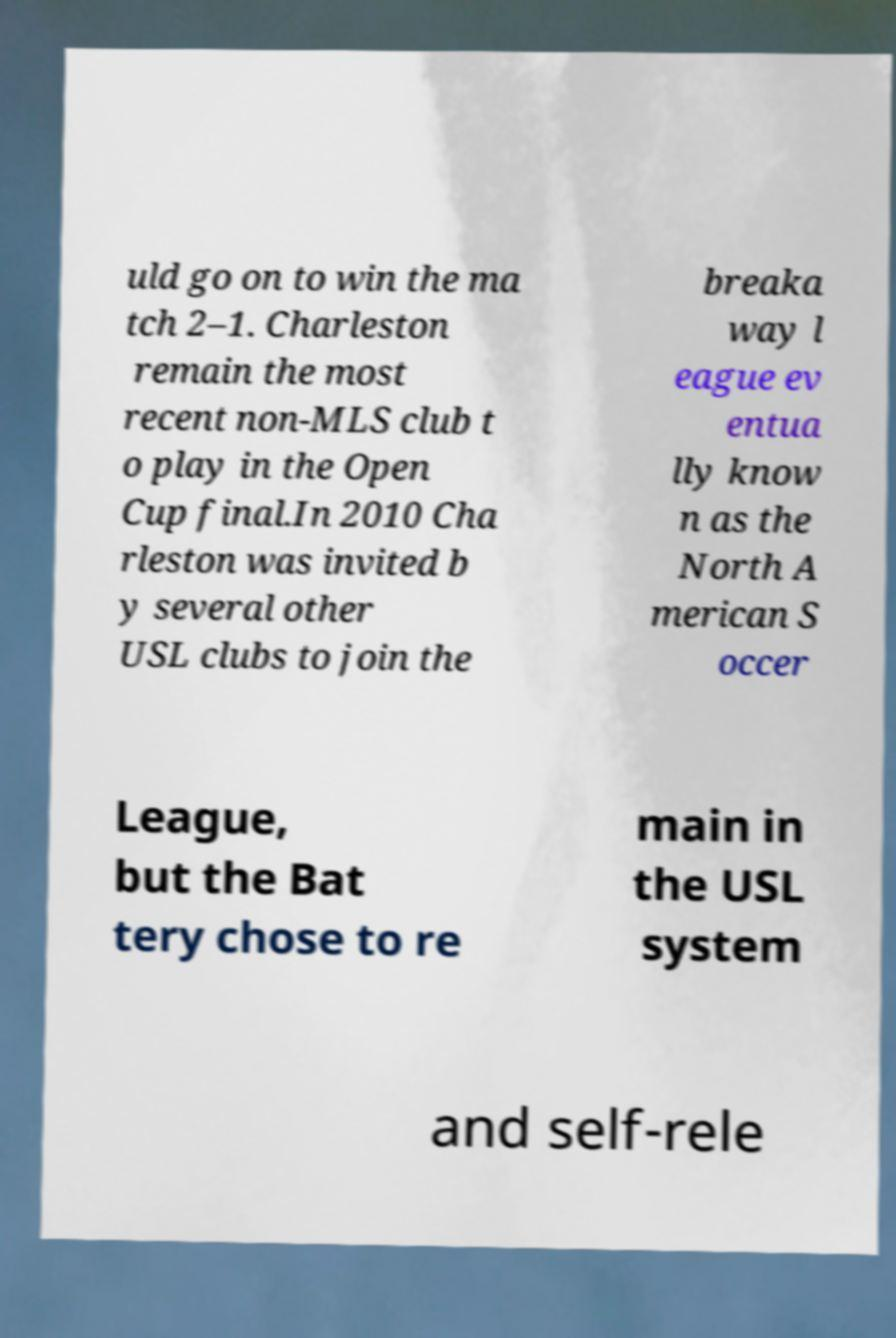For documentation purposes, I need the text within this image transcribed. Could you provide that? uld go on to win the ma tch 2–1. Charleston remain the most recent non-MLS club t o play in the Open Cup final.In 2010 Cha rleston was invited b y several other USL clubs to join the breaka way l eague ev entua lly know n as the North A merican S occer League, but the Bat tery chose to re main in the USL system and self-rele 